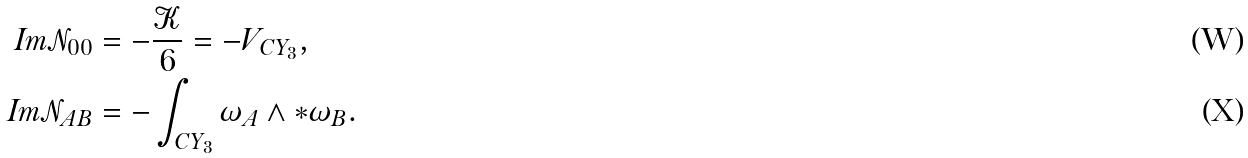Convert formula to latex. <formula><loc_0><loc_0><loc_500><loc_500>\text {Im} \mathcal { N } _ { 0 0 } & = - \frac { \mathcal { K } } { 6 } = - V _ { \text {CY} _ { 3 } } , \\ \text {Im} \mathcal { N } _ { A B } & = - \int _ { \text {CY} _ { 3 } } \omega _ { A } \wedge * \omega _ { B } .</formula> 